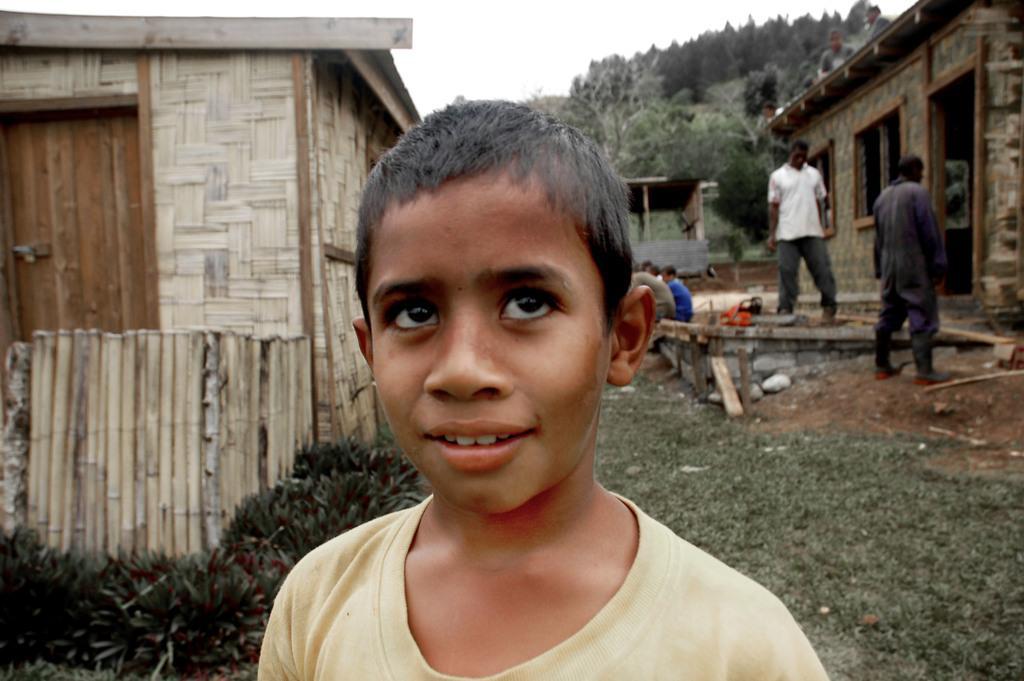In one or two sentences, can you explain what this image depicts? In this image I can see in the middle there is a boy, he is looking at the top. It looks like there are wooden houses on either side of this image, on the right side few people are there. In the background there are trees, at the top there is the sky. 